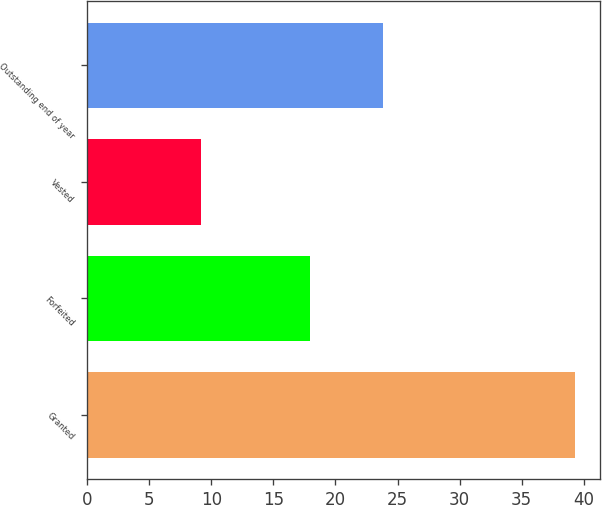Convert chart. <chart><loc_0><loc_0><loc_500><loc_500><bar_chart><fcel>Granted<fcel>Forfeited<fcel>Vested<fcel>Outstanding end of year<nl><fcel>39.32<fcel>17.93<fcel>9.16<fcel>23.81<nl></chart> 